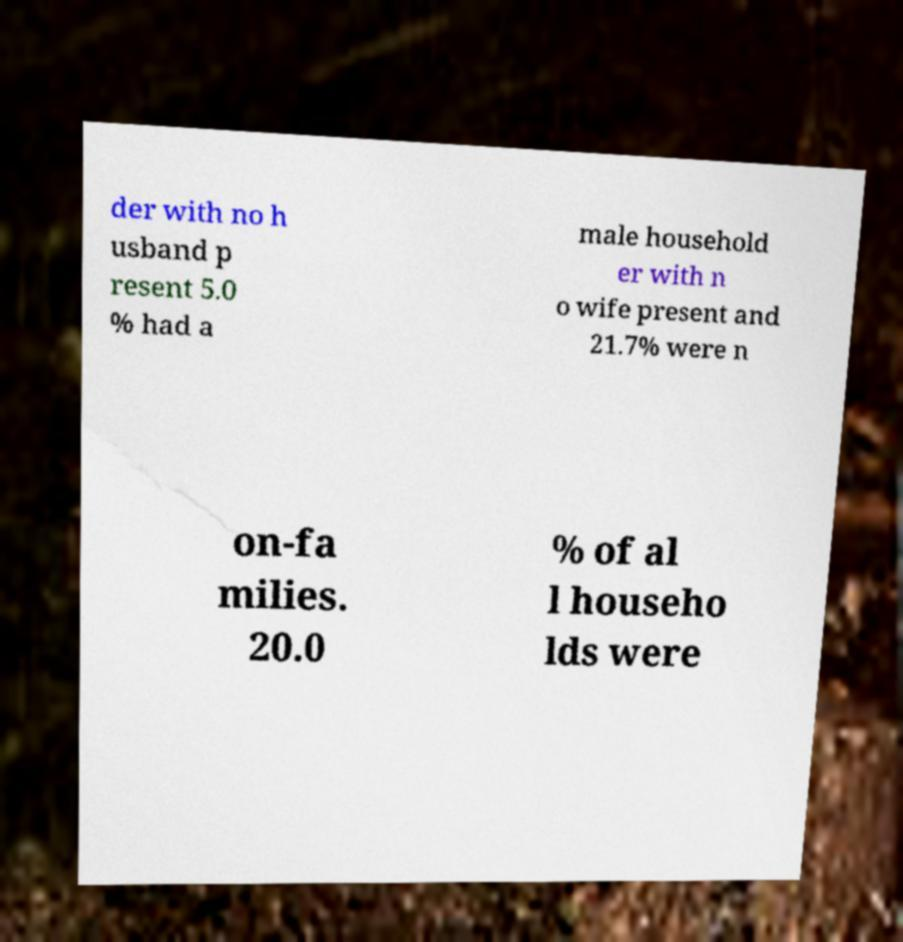Can you accurately transcribe the text from the provided image for me? der with no h usband p resent 5.0 % had a male household er with n o wife present and 21.7% were n on-fa milies. 20.0 % of al l househo lds were 